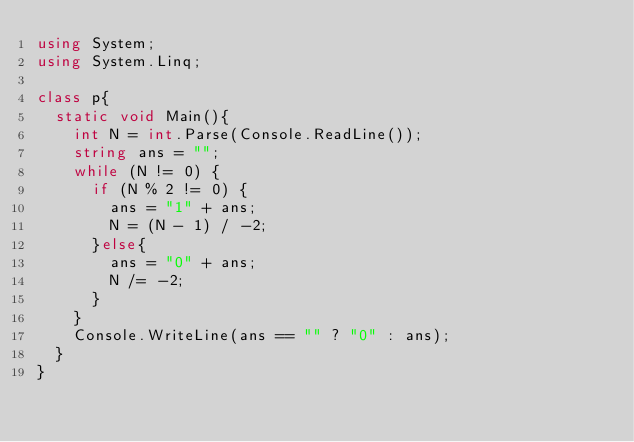Convert code to text. <code><loc_0><loc_0><loc_500><loc_500><_C#_>using System;
using System.Linq;

class p{
  static void Main(){
    int N = int.Parse(Console.ReadLine());
    string ans = "";
    while (N != 0) {
      if (N % 2 != 0) {
        ans = "1" + ans;
        N = (N - 1) / -2;
      }else{
        ans = "0" + ans;
        N /= -2;
      }
    }
    Console.WriteLine(ans == "" ? "0" : ans);
  }
}</code> 